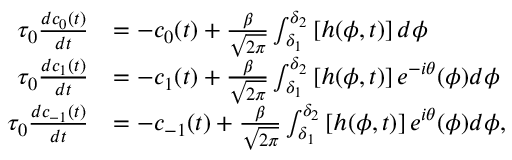Convert formula to latex. <formula><loc_0><loc_0><loc_500><loc_500>\begin{array} { r l } { \tau _ { 0 } \frac { d c _ { 0 } ( t ) } { d t } } & { = - c _ { 0 } ( t ) + \frac { \beta } { \sqrt { 2 \pi } } \int _ { \delta _ { 1 } } ^ { \delta _ { 2 } } \left [ h ( \phi , t ) \right ] d \phi } \\ { \tau _ { 0 } \frac { d c _ { 1 } ( t ) } { d t } } & { = - c _ { 1 } ( t ) + \frac { \beta } { \sqrt { 2 \pi } } \int _ { \delta _ { 1 } } ^ { \delta _ { 2 } } \left [ h ( \phi , t ) \right ] e ^ { - i \theta } ( \phi ) d \phi } \\ { \tau _ { 0 } \frac { d c _ { - 1 } ( t ) } { d t } } & { = - c _ { - 1 } ( t ) + \frac { \beta } { \sqrt { 2 \pi } } \int _ { \delta _ { 1 } } ^ { \delta _ { 2 } } \left [ h ( \phi , t ) \right ] e ^ { i \theta } ( \phi ) d \phi , } \end{array}</formula> 